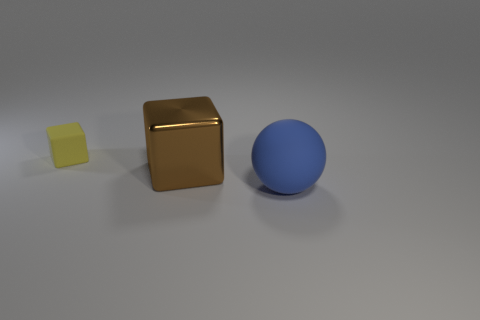What is the material of the block that is left of the cube right of the rubber thing that is on the left side of the matte ball?
Your response must be concise. Rubber. There is a rubber thing on the right side of the small yellow thing; is its color the same as the shiny cube?
Provide a short and direct response. No. What is the object that is behind the large blue thing and in front of the tiny yellow object made of?
Make the answer very short. Metal. Are there any yellow cubes that have the same size as the brown object?
Offer a very short reply. No. How many large cubes are there?
Ensure brevity in your answer.  1. There is a rubber cube; what number of small yellow rubber things are to the right of it?
Ensure brevity in your answer.  0. Do the big blue ball and the brown cube have the same material?
Your answer should be compact. No. How many things are on the right side of the tiny yellow block and on the left side of the big rubber object?
Keep it short and to the point. 1. What number of other objects are the same color as the small block?
Offer a very short reply. 0. What number of cyan things are small blocks or metallic things?
Make the answer very short. 0. 